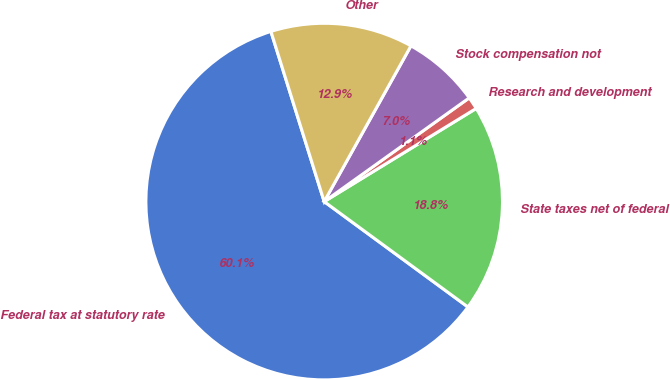Convert chart. <chart><loc_0><loc_0><loc_500><loc_500><pie_chart><fcel>Federal tax at statutory rate<fcel>State taxes net of federal<fcel>Research and development<fcel>Stock compensation not<fcel>Other<nl><fcel>60.1%<fcel>18.82%<fcel>1.13%<fcel>7.03%<fcel>12.92%<nl></chart> 